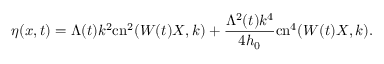Convert formula to latex. <formula><loc_0><loc_0><loc_500><loc_500>\eta ( x , t ) = \Lambda ( t ) k ^ { 2 } c n ^ { 2 } ( W ( t ) X , k ) + \frac { \Lambda ^ { 2 } ( t ) k ^ { 4 } } { 4 h _ { 0 } } c n ^ { 4 } ( W ( t ) X , k ) .</formula> 